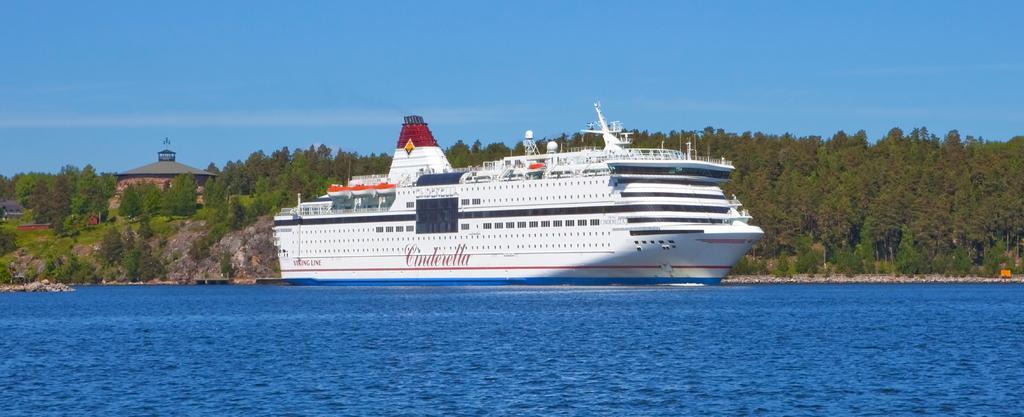Could you give a brief overview of what you see in this image? In this image I can see the water and a huge ship which is white and blue in color on the surface of the water. In the background I can see the ground, few trees which are green in color on the ground, few buildings and the sky. 